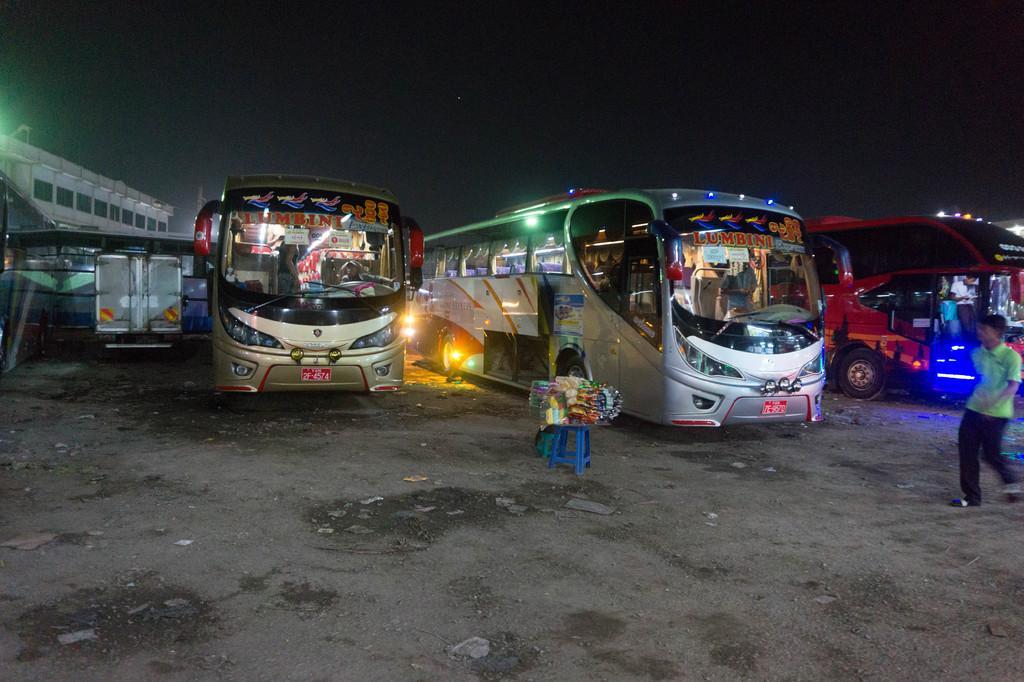How would you summarize this image in a sentence or two? In this image I can see few buses on the road. They are in different color. We can see few packets on the blue color stool. I can see person standing. Back Side I can see building and windows. 